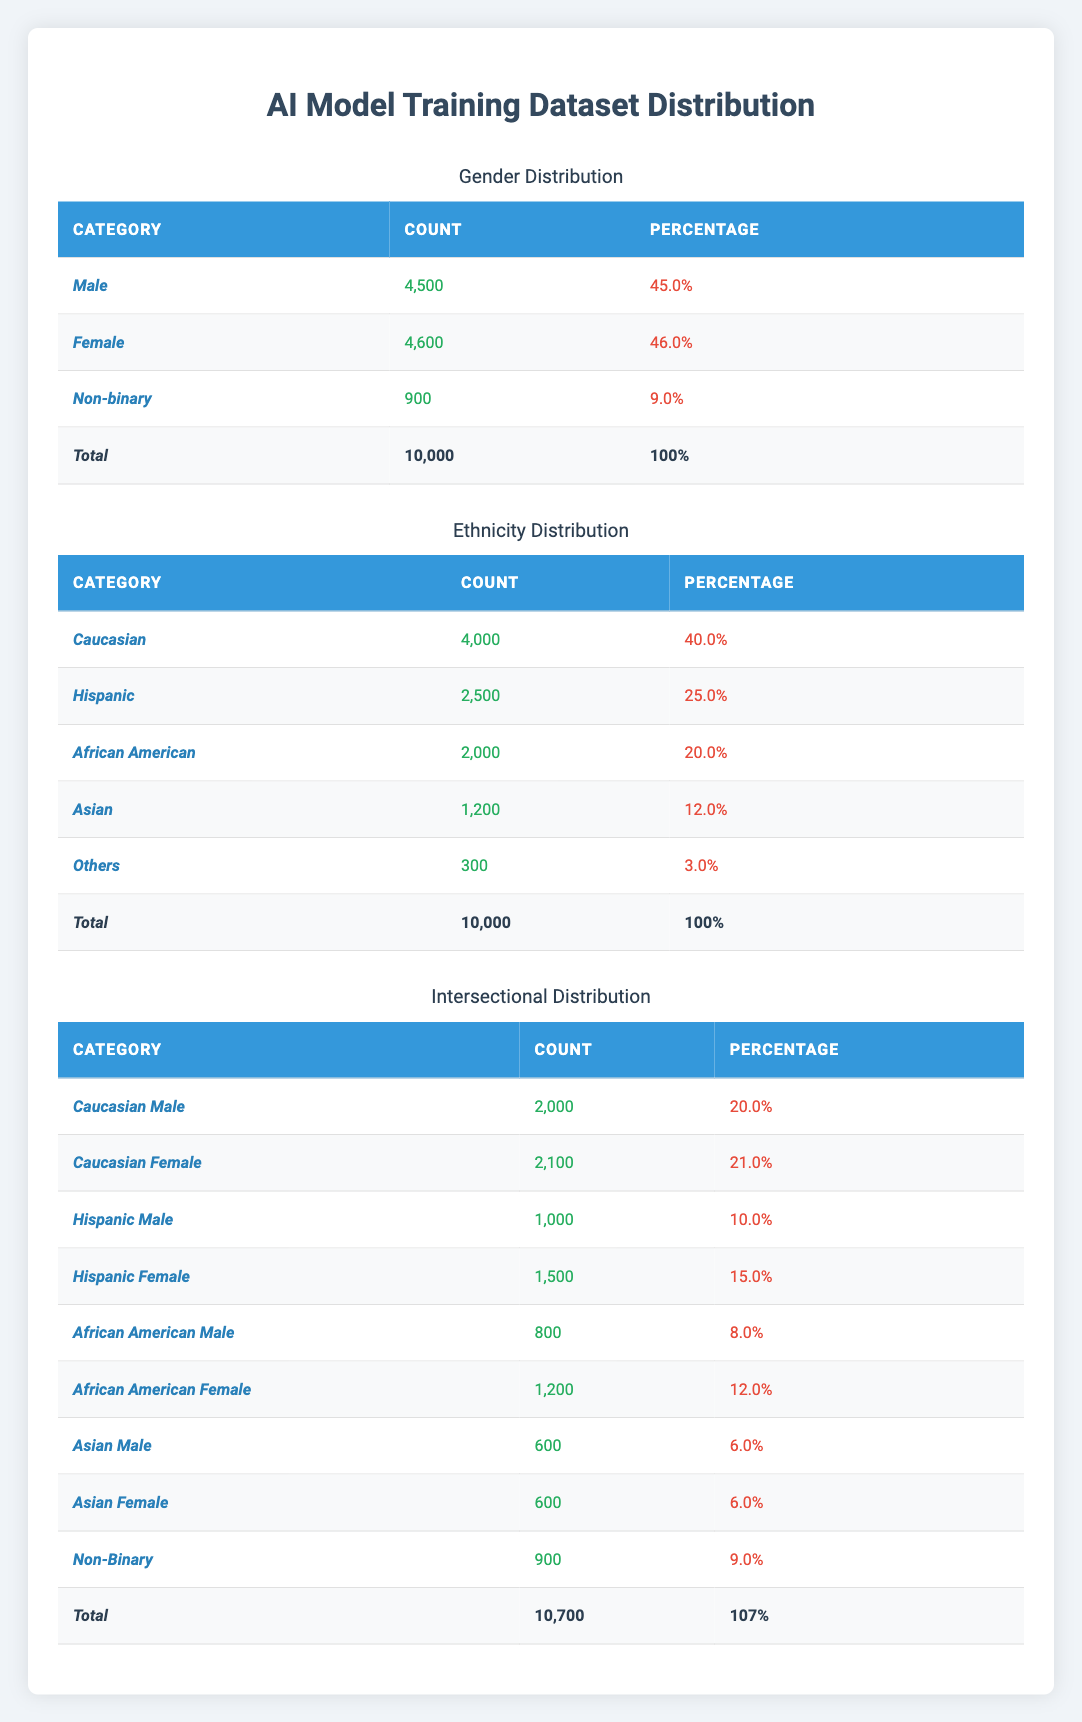What is the total number of samples in the training dataset? The total number of samples is stated directly in the table under the "Total" row of the Gender Distribution section as 10,000.
Answer: 10,000 What percentage of the training dataset is male? The percentage of male samples is specified as 45.0% in the Gender Distribution section of the table.
Answer: 45.0% How many female samples are recorded in the training dataset? The count of female samples is listed as 4,600 in the Gender Distribution section.
Answer: 4,600 What is the ethnic group with the highest representation in the dataset? The ethnic group with the highest count is Caucasian, with 4,000 samples, which is more than any other group listed.
Answer: Caucasian What percentage of the dataset is composed of African American males? The percentage of African American males is indicated as 8.0% in the Intersectional Distribution section of the table.
Answer: 8.0% How many total Hispanic individuals are in the dataset? The total of Hispanic individuals can be calculated by summing Hispanic males (1,000) and Hispanic females (1,500), giving 2,500.
Answer: 2,500 Is the count of non-binary individuals greater or lesser than the count of African American females? The count of non-binary individuals is 900, while the count of African American females is 1,200, therefore, the non-binary count is lesser.
Answer: Lesser What is the overall percentage of females (including non-binary) in the dataset? The percentage of females is 46.0%, and non-binary individuals do not affect this percentage directly as they are a separate category; thus the total for females remains 46.0%.
Answer: 46.0% Which group has the lowest representation in the training dataset based on ethnicity? The "Others" category has the lowest count, at 300 samples, compared to all other ethnic groups.
Answer: Others What is the combined total of Caucasian and Hispanic females in the dataset? Caucasian females count is 2,100, and Hispanic females count is 1,500. Their sum is 2,100 + 1,500 = 3,600.
Answer: 3,600 How does the total sample count in the intersectional distribution compare to the overall sample count? The total sample count in the intersectional distribution is 10,700, which is greater than the overall sample count of 10,000.
Answer: Greater Calculate the percentage of total Asian males in relation to the overall dataset. The count of Asian males is 600. To find the percentage, (600/10,000) x 100 = 6.0%.
Answer: 6.0% What is the count difference between African American males and females? The count of African American males is 800 and African American females is 1,200. The difference is 1,200 - 800 = 400.
Answer: 400 How many more females are there than males in the overall dataset? The count of females is 4,600 and the count of males is 4,500. The difference is 4,600 - 4,500 = 100.
Answer: 100 Is the percentage of Caucasian males equal to the percentage of Asian females in the dataset? The percentage of Caucasian males is 20.0% and the percentage of Asian females is also 6.0%, indicating they are not equal.
Answer: No 